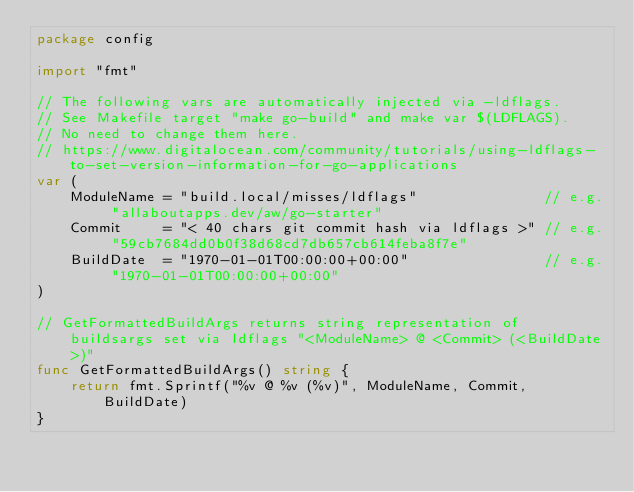Convert code to text. <code><loc_0><loc_0><loc_500><loc_500><_Go_>package config

import "fmt"

// The following vars are automatically injected via -ldflags.
// See Makefile target "make go-build" and make var $(LDFLAGS).
// No need to change them here.
// https://www.digitalocean.com/community/tutorials/using-ldflags-to-set-version-information-for-go-applications
var (
	ModuleName = "build.local/misses/ldflags"               // e.g. "allaboutapps.dev/aw/go-starter"
	Commit     = "< 40 chars git commit hash via ldflags >" // e.g. "59cb7684dd0b0f38d68cd7db657cb614feba8f7e"
	BuildDate  = "1970-01-01T00:00:00+00:00"                // e.g. "1970-01-01T00:00:00+00:00"
)

// GetFormattedBuildArgs returns string representation of buildsargs set via ldflags "<ModuleName> @ <Commit> (<BuildDate>)"
func GetFormattedBuildArgs() string {
	return fmt.Sprintf("%v @ %v (%v)", ModuleName, Commit, BuildDate)
}
</code> 